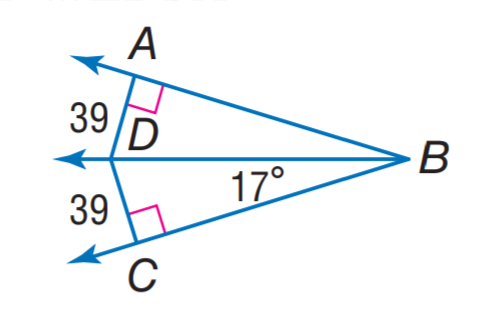Can you explain why the triangle inside the larger triangle is also an isosceles triangle? Yes, triangle ADB is an isosceles triangle because it has two equal angles of 39 degrees at vertices A and B. This means that sides AD and BD are equal in length. An isosceles triangle is defined as having at least two sides of equal length, corresponding to the two equal angles. 